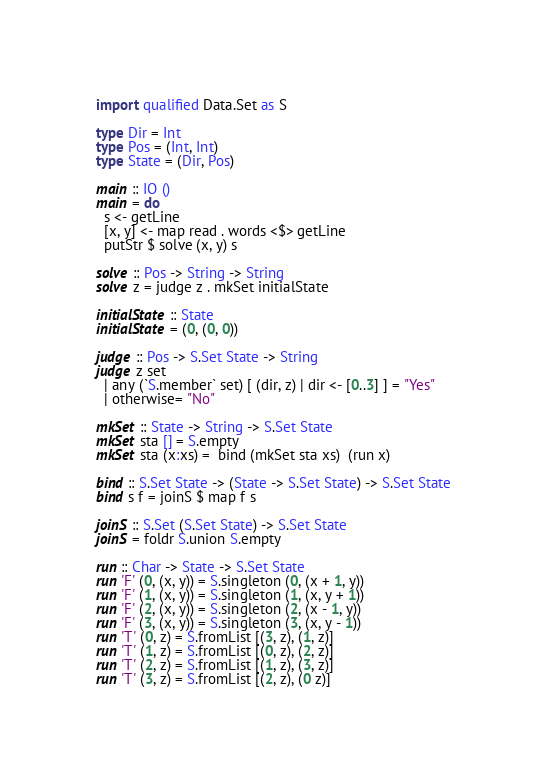<code> <loc_0><loc_0><loc_500><loc_500><_Haskell_>import qualified Data.Set as S
 
type Dir = Int
type Pos = (Int, Int)
type State = (Dir, Pos)
 
main :: IO ()
main = do
  s <- getLine
  [x, y] <- map read . words <$> getLine
  putStr $ solve (x, y) s
 
solve :: Pos -> String -> String
solve z = judge z . mkSet initialState
 
initialState :: State
initialState = (0, (0, 0))
 
judge :: Pos -> S.Set State -> String
judge z set
  | any (`S.member` set) [ (dir, z) | dir <- [0..3] ] = "Yes"
  | otherwise= "No"
 
mkSet :: State -> String -> S.Set State
mkSet sta [] = S.empty
mkSet sta (x:xs) =  bind (mkSet sta xs)  (run x)
 
bind :: S.Set State -> (State -> S.Set State) -> S.Set State
bind s f = joinS $ map f s
 
joinS :: S.Set (S.Set State) -> S.Set State
joinS = foldr S.union S.empty
 
run :: Char -> State -> S.Set State
run 'F' (0, (x, y)) = S.singleton (0, (x + 1, y))
run 'F' (1, (x, y)) = S.singleton (1, (x, y + 1))
run 'F' (2, (x, y)) = S.singleton (2, (x - 1, y))
run 'F' (3, (x, y)) = S.singleton (3, (x, y - 1))
run 'T' (0, z) = S.fromList [(3, z), (1, z)]
run 'T' (1, z) = S.fromList [(0, z), (2, z)]
run 'T' (2, z) = S.fromList [(1, z), (3, z)]
run 'T' (3, z) = S.fromList [(2, z), (0 z)]</code> 